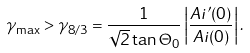Convert formula to latex. <formula><loc_0><loc_0><loc_500><loc_500>\gamma _ { \max } > \gamma _ { 8 / 3 } = \frac { 1 } { \sqrt { 2 } \tan { \Theta _ { 0 } } } \left | \frac { A i ^ { \prime } ( 0 ) } { A i ( 0 ) } \right | .</formula> 